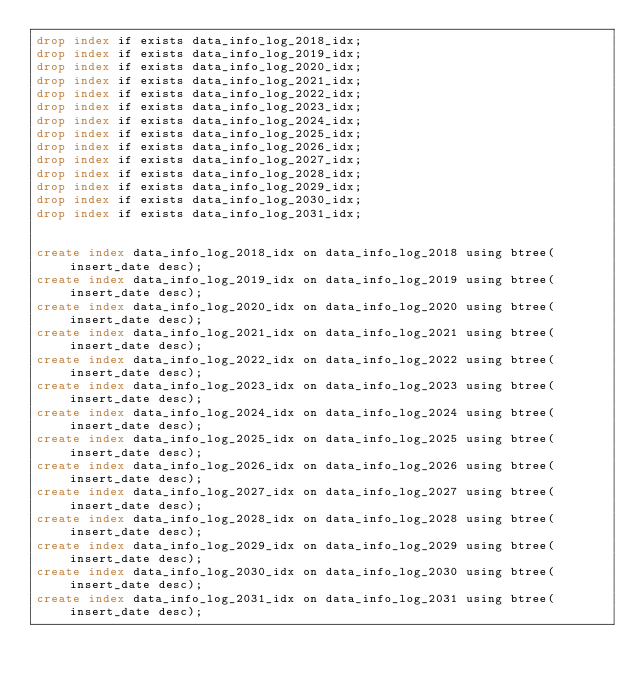<code> <loc_0><loc_0><loc_500><loc_500><_SQL_>drop index if exists data_info_log_2018_idx;
drop index if exists data_info_log_2019_idx;
drop index if exists data_info_log_2020_idx;
drop index if exists data_info_log_2021_idx;
drop index if exists data_info_log_2022_idx;
drop index if exists data_info_log_2023_idx;
drop index if exists data_info_log_2024_idx;
drop index if exists data_info_log_2025_idx;
drop index if exists data_info_log_2026_idx;
drop index if exists data_info_log_2027_idx;
drop index if exists data_info_log_2028_idx;
drop index if exists data_info_log_2029_idx;
drop index if exists data_info_log_2030_idx;
drop index if exists data_info_log_2031_idx;


create index data_info_log_2018_idx on data_info_log_2018 using btree(insert_date desc);
create index data_info_log_2019_idx on data_info_log_2019 using btree(insert_date desc);
create index data_info_log_2020_idx on data_info_log_2020 using btree(insert_date desc);
create index data_info_log_2021_idx on data_info_log_2021 using btree(insert_date desc);
create index data_info_log_2022_idx on data_info_log_2022 using btree(insert_date desc);
create index data_info_log_2023_idx on data_info_log_2023 using btree(insert_date desc);
create index data_info_log_2024_idx on data_info_log_2024 using btree(insert_date desc);
create index data_info_log_2025_idx on data_info_log_2025 using btree(insert_date desc);
create index data_info_log_2026_idx on data_info_log_2026 using btree(insert_date desc);
create index data_info_log_2027_idx on data_info_log_2027 using btree(insert_date desc);
create index data_info_log_2028_idx on data_info_log_2028 using btree(insert_date desc);
create index data_info_log_2029_idx on data_info_log_2029 using btree(insert_date desc);
create index data_info_log_2030_idx on data_info_log_2030 using btree(insert_date desc);
create index data_info_log_2031_idx on data_info_log_2031 using btree(insert_date desc);
</code> 